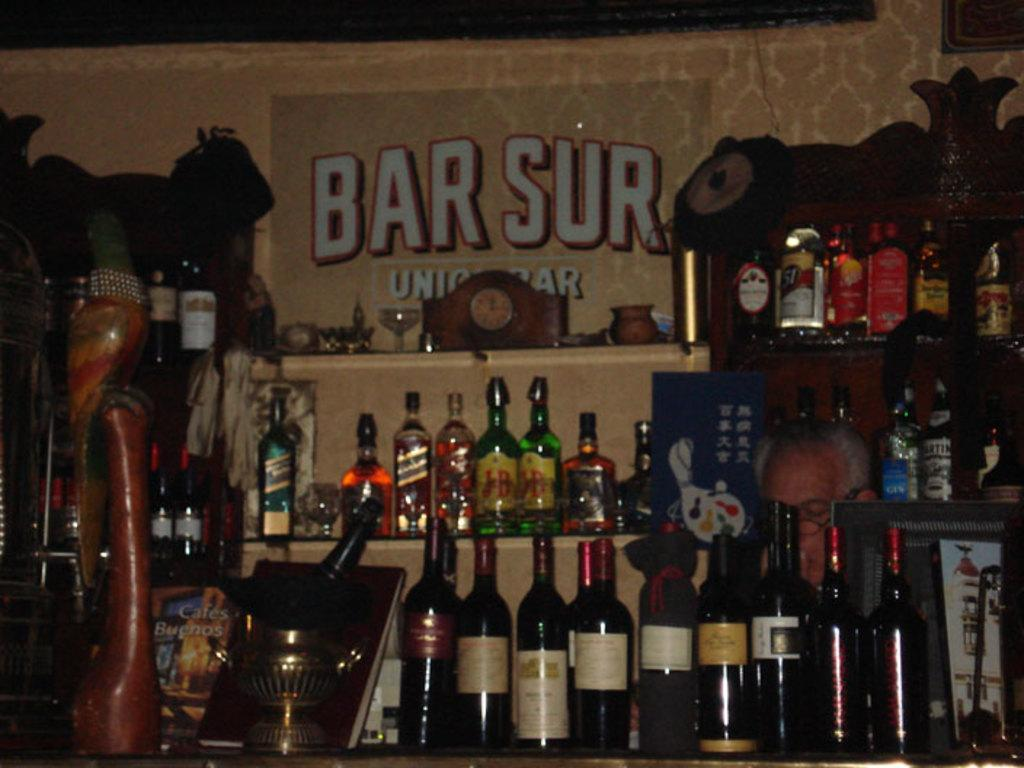<image>
Create a compact narrative representing the image presented. Different bottles of alcohol are lined up at Bar Sur. 